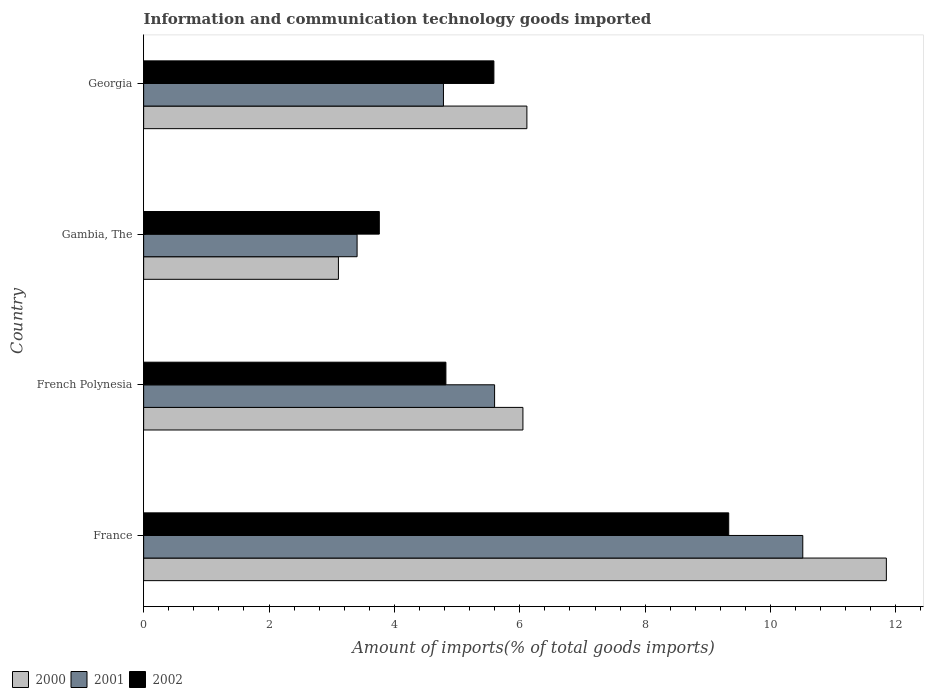How many different coloured bars are there?
Your answer should be compact. 3. How many groups of bars are there?
Offer a very short reply. 4. Are the number of bars per tick equal to the number of legend labels?
Your answer should be compact. Yes. Are the number of bars on each tick of the Y-axis equal?
Keep it short and to the point. Yes. How many bars are there on the 3rd tick from the top?
Provide a succinct answer. 3. What is the label of the 3rd group of bars from the top?
Offer a very short reply. French Polynesia. In how many cases, is the number of bars for a given country not equal to the number of legend labels?
Your answer should be very brief. 0. What is the amount of goods imported in 2000 in French Polynesia?
Offer a terse response. 6.05. Across all countries, what is the maximum amount of goods imported in 2000?
Keep it short and to the point. 11.85. Across all countries, what is the minimum amount of goods imported in 2000?
Give a very brief answer. 3.11. In which country was the amount of goods imported in 2001 minimum?
Ensure brevity in your answer.  Gambia, The. What is the total amount of goods imported in 2002 in the graph?
Offer a terse response. 23.5. What is the difference between the amount of goods imported in 2001 in French Polynesia and that in Gambia, The?
Your answer should be very brief. 2.19. What is the difference between the amount of goods imported in 2000 in Gambia, The and the amount of goods imported in 2001 in Georgia?
Provide a succinct answer. -1.68. What is the average amount of goods imported in 2002 per country?
Provide a short and direct response. 5.88. What is the difference between the amount of goods imported in 2000 and amount of goods imported in 2001 in France?
Give a very brief answer. 1.33. What is the ratio of the amount of goods imported in 2002 in France to that in French Polynesia?
Your answer should be very brief. 1.94. What is the difference between the highest and the second highest amount of goods imported in 2001?
Ensure brevity in your answer.  4.92. What is the difference between the highest and the lowest amount of goods imported in 2001?
Give a very brief answer. 7.11. Is the sum of the amount of goods imported in 2000 in France and French Polynesia greater than the maximum amount of goods imported in 2001 across all countries?
Your answer should be compact. Yes. Is it the case that in every country, the sum of the amount of goods imported in 2002 and amount of goods imported in 2000 is greater than the amount of goods imported in 2001?
Offer a very short reply. Yes. How many bars are there?
Your answer should be compact. 12. Are the values on the major ticks of X-axis written in scientific E-notation?
Offer a very short reply. No. Does the graph contain any zero values?
Ensure brevity in your answer.  No. Where does the legend appear in the graph?
Keep it short and to the point. Bottom left. How are the legend labels stacked?
Offer a very short reply. Horizontal. What is the title of the graph?
Your answer should be compact. Information and communication technology goods imported. What is the label or title of the X-axis?
Provide a succinct answer. Amount of imports(% of total goods imports). What is the label or title of the Y-axis?
Keep it short and to the point. Country. What is the Amount of imports(% of total goods imports) in 2000 in France?
Your response must be concise. 11.85. What is the Amount of imports(% of total goods imports) in 2001 in France?
Keep it short and to the point. 10.51. What is the Amount of imports(% of total goods imports) in 2002 in France?
Ensure brevity in your answer.  9.33. What is the Amount of imports(% of total goods imports) of 2000 in French Polynesia?
Your answer should be compact. 6.05. What is the Amount of imports(% of total goods imports) in 2001 in French Polynesia?
Offer a very short reply. 5.6. What is the Amount of imports(% of total goods imports) of 2002 in French Polynesia?
Ensure brevity in your answer.  4.82. What is the Amount of imports(% of total goods imports) of 2000 in Gambia, The?
Provide a short and direct response. 3.11. What is the Amount of imports(% of total goods imports) in 2001 in Gambia, The?
Ensure brevity in your answer.  3.4. What is the Amount of imports(% of total goods imports) in 2002 in Gambia, The?
Provide a succinct answer. 3.76. What is the Amount of imports(% of total goods imports) in 2000 in Georgia?
Provide a short and direct response. 6.11. What is the Amount of imports(% of total goods imports) in 2001 in Georgia?
Keep it short and to the point. 4.78. What is the Amount of imports(% of total goods imports) of 2002 in Georgia?
Provide a short and direct response. 5.59. Across all countries, what is the maximum Amount of imports(% of total goods imports) of 2000?
Your answer should be very brief. 11.85. Across all countries, what is the maximum Amount of imports(% of total goods imports) of 2001?
Provide a short and direct response. 10.51. Across all countries, what is the maximum Amount of imports(% of total goods imports) in 2002?
Ensure brevity in your answer.  9.33. Across all countries, what is the minimum Amount of imports(% of total goods imports) in 2000?
Offer a terse response. 3.11. Across all countries, what is the minimum Amount of imports(% of total goods imports) of 2001?
Ensure brevity in your answer.  3.4. Across all countries, what is the minimum Amount of imports(% of total goods imports) in 2002?
Offer a terse response. 3.76. What is the total Amount of imports(% of total goods imports) in 2000 in the graph?
Your answer should be very brief. 27.12. What is the total Amount of imports(% of total goods imports) in 2001 in the graph?
Offer a very short reply. 24.3. What is the total Amount of imports(% of total goods imports) of 2002 in the graph?
Your answer should be compact. 23.5. What is the difference between the Amount of imports(% of total goods imports) in 2000 in France and that in French Polynesia?
Provide a succinct answer. 5.8. What is the difference between the Amount of imports(% of total goods imports) of 2001 in France and that in French Polynesia?
Your answer should be compact. 4.92. What is the difference between the Amount of imports(% of total goods imports) in 2002 in France and that in French Polynesia?
Offer a terse response. 4.51. What is the difference between the Amount of imports(% of total goods imports) of 2000 in France and that in Gambia, The?
Offer a terse response. 8.74. What is the difference between the Amount of imports(% of total goods imports) of 2001 in France and that in Gambia, The?
Offer a very short reply. 7.11. What is the difference between the Amount of imports(% of total goods imports) of 2002 in France and that in Gambia, The?
Ensure brevity in your answer.  5.57. What is the difference between the Amount of imports(% of total goods imports) in 2000 in France and that in Georgia?
Your answer should be compact. 5.73. What is the difference between the Amount of imports(% of total goods imports) of 2001 in France and that in Georgia?
Your response must be concise. 5.73. What is the difference between the Amount of imports(% of total goods imports) in 2002 in France and that in Georgia?
Provide a short and direct response. 3.75. What is the difference between the Amount of imports(% of total goods imports) of 2000 in French Polynesia and that in Gambia, The?
Provide a short and direct response. 2.94. What is the difference between the Amount of imports(% of total goods imports) in 2001 in French Polynesia and that in Gambia, The?
Provide a short and direct response. 2.19. What is the difference between the Amount of imports(% of total goods imports) of 2002 in French Polynesia and that in Gambia, The?
Provide a succinct answer. 1.06. What is the difference between the Amount of imports(% of total goods imports) in 2000 in French Polynesia and that in Georgia?
Give a very brief answer. -0.06. What is the difference between the Amount of imports(% of total goods imports) of 2001 in French Polynesia and that in Georgia?
Provide a succinct answer. 0.82. What is the difference between the Amount of imports(% of total goods imports) of 2002 in French Polynesia and that in Georgia?
Provide a succinct answer. -0.77. What is the difference between the Amount of imports(% of total goods imports) in 2000 in Gambia, The and that in Georgia?
Your response must be concise. -3.01. What is the difference between the Amount of imports(% of total goods imports) in 2001 in Gambia, The and that in Georgia?
Your answer should be very brief. -1.38. What is the difference between the Amount of imports(% of total goods imports) of 2002 in Gambia, The and that in Georgia?
Your answer should be compact. -1.83. What is the difference between the Amount of imports(% of total goods imports) in 2000 in France and the Amount of imports(% of total goods imports) in 2001 in French Polynesia?
Offer a terse response. 6.25. What is the difference between the Amount of imports(% of total goods imports) in 2000 in France and the Amount of imports(% of total goods imports) in 2002 in French Polynesia?
Offer a very short reply. 7.03. What is the difference between the Amount of imports(% of total goods imports) in 2001 in France and the Amount of imports(% of total goods imports) in 2002 in French Polynesia?
Your answer should be very brief. 5.69. What is the difference between the Amount of imports(% of total goods imports) of 2000 in France and the Amount of imports(% of total goods imports) of 2001 in Gambia, The?
Offer a terse response. 8.44. What is the difference between the Amount of imports(% of total goods imports) in 2000 in France and the Amount of imports(% of total goods imports) in 2002 in Gambia, The?
Keep it short and to the point. 8.09. What is the difference between the Amount of imports(% of total goods imports) in 2001 in France and the Amount of imports(% of total goods imports) in 2002 in Gambia, The?
Offer a terse response. 6.76. What is the difference between the Amount of imports(% of total goods imports) of 2000 in France and the Amount of imports(% of total goods imports) of 2001 in Georgia?
Your answer should be very brief. 7.07. What is the difference between the Amount of imports(% of total goods imports) of 2000 in France and the Amount of imports(% of total goods imports) of 2002 in Georgia?
Provide a succinct answer. 6.26. What is the difference between the Amount of imports(% of total goods imports) of 2001 in France and the Amount of imports(% of total goods imports) of 2002 in Georgia?
Keep it short and to the point. 4.93. What is the difference between the Amount of imports(% of total goods imports) in 2000 in French Polynesia and the Amount of imports(% of total goods imports) in 2001 in Gambia, The?
Give a very brief answer. 2.65. What is the difference between the Amount of imports(% of total goods imports) of 2000 in French Polynesia and the Amount of imports(% of total goods imports) of 2002 in Gambia, The?
Make the answer very short. 2.29. What is the difference between the Amount of imports(% of total goods imports) of 2001 in French Polynesia and the Amount of imports(% of total goods imports) of 2002 in Gambia, The?
Ensure brevity in your answer.  1.84. What is the difference between the Amount of imports(% of total goods imports) in 2000 in French Polynesia and the Amount of imports(% of total goods imports) in 2001 in Georgia?
Keep it short and to the point. 1.27. What is the difference between the Amount of imports(% of total goods imports) in 2000 in French Polynesia and the Amount of imports(% of total goods imports) in 2002 in Georgia?
Your answer should be very brief. 0.46. What is the difference between the Amount of imports(% of total goods imports) in 2001 in French Polynesia and the Amount of imports(% of total goods imports) in 2002 in Georgia?
Your response must be concise. 0.01. What is the difference between the Amount of imports(% of total goods imports) of 2000 in Gambia, The and the Amount of imports(% of total goods imports) of 2001 in Georgia?
Keep it short and to the point. -1.68. What is the difference between the Amount of imports(% of total goods imports) in 2000 in Gambia, The and the Amount of imports(% of total goods imports) in 2002 in Georgia?
Your answer should be compact. -2.48. What is the difference between the Amount of imports(% of total goods imports) of 2001 in Gambia, The and the Amount of imports(% of total goods imports) of 2002 in Georgia?
Keep it short and to the point. -2.18. What is the average Amount of imports(% of total goods imports) in 2000 per country?
Provide a succinct answer. 6.78. What is the average Amount of imports(% of total goods imports) in 2001 per country?
Provide a succinct answer. 6.08. What is the average Amount of imports(% of total goods imports) of 2002 per country?
Offer a very short reply. 5.88. What is the difference between the Amount of imports(% of total goods imports) of 2000 and Amount of imports(% of total goods imports) of 2001 in France?
Your response must be concise. 1.33. What is the difference between the Amount of imports(% of total goods imports) of 2000 and Amount of imports(% of total goods imports) of 2002 in France?
Keep it short and to the point. 2.51. What is the difference between the Amount of imports(% of total goods imports) in 2001 and Amount of imports(% of total goods imports) in 2002 in France?
Provide a short and direct response. 1.18. What is the difference between the Amount of imports(% of total goods imports) of 2000 and Amount of imports(% of total goods imports) of 2001 in French Polynesia?
Offer a very short reply. 0.45. What is the difference between the Amount of imports(% of total goods imports) in 2000 and Amount of imports(% of total goods imports) in 2002 in French Polynesia?
Give a very brief answer. 1.23. What is the difference between the Amount of imports(% of total goods imports) in 2001 and Amount of imports(% of total goods imports) in 2002 in French Polynesia?
Your answer should be compact. 0.78. What is the difference between the Amount of imports(% of total goods imports) in 2000 and Amount of imports(% of total goods imports) in 2001 in Gambia, The?
Keep it short and to the point. -0.3. What is the difference between the Amount of imports(% of total goods imports) of 2000 and Amount of imports(% of total goods imports) of 2002 in Gambia, The?
Offer a very short reply. -0.65. What is the difference between the Amount of imports(% of total goods imports) of 2001 and Amount of imports(% of total goods imports) of 2002 in Gambia, The?
Keep it short and to the point. -0.35. What is the difference between the Amount of imports(% of total goods imports) in 2000 and Amount of imports(% of total goods imports) in 2001 in Georgia?
Give a very brief answer. 1.33. What is the difference between the Amount of imports(% of total goods imports) of 2000 and Amount of imports(% of total goods imports) of 2002 in Georgia?
Make the answer very short. 0.53. What is the difference between the Amount of imports(% of total goods imports) of 2001 and Amount of imports(% of total goods imports) of 2002 in Georgia?
Offer a very short reply. -0.8. What is the ratio of the Amount of imports(% of total goods imports) in 2000 in France to that in French Polynesia?
Your answer should be very brief. 1.96. What is the ratio of the Amount of imports(% of total goods imports) of 2001 in France to that in French Polynesia?
Your answer should be compact. 1.88. What is the ratio of the Amount of imports(% of total goods imports) of 2002 in France to that in French Polynesia?
Make the answer very short. 1.94. What is the ratio of the Amount of imports(% of total goods imports) of 2000 in France to that in Gambia, The?
Provide a succinct answer. 3.81. What is the ratio of the Amount of imports(% of total goods imports) of 2001 in France to that in Gambia, The?
Keep it short and to the point. 3.09. What is the ratio of the Amount of imports(% of total goods imports) in 2002 in France to that in Gambia, The?
Your response must be concise. 2.48. What is the ratio of the Amount of imports(% of total goods imports) in 2000 in France to that in Georgia?
Offer a terse response. 1.94. What is the ratio of the Amount of imports(% of total goods imports) of 2001 in France to that in Georgia?
Provide a succinct answer. 2.2. What is the ratio of the Amount of imports(% of total goods imports) of 2002 in France to that in Georgia?
Offer a very short reply. 1.67. What is the ratio of the Amount of imports(% of total goods imports) of 2000 in French Polynesia to that in Gambia, The?
Ensure brevity in your answer.  1.95. What is the ratio of the Amount of imports(% of total goods imports) of 2001 in French Polynesia to that in Gambia, The?
Your answer should be compact. 1.64. What is the ratio of the Amount of imports(% of total goods imports) in 2002 in French Polynesia to that in Gambia, The?
Make the answer very short. 1.28. What is the ratio of the Amount of imports(% of total goods imports) of 2000 in French Polynesia to that in Georgia?
Your answer should be compact. 0.99. What is the ratio of the Amount of imports(% of total goods imports) in 2001 in French Polynesia to that in Georgia?
Offer a very short reply. 1.17. What is the ratio of the Amount of imports(% of total goods imports) in 2002 in French Polynesia to that in Georgia?
Provide a short and direct response. 0.86. What is the ratio of the Amount of imports(% of total goods imports) in 2000 in Gambia, The to that in Georgia?
Your answer should be very brief. 0.51. What is the ratio of the Amount of imports(% of total goods imports) of 2001 in Gambia, The to that in Georgia?
Make the answer very short. 0.71. What is the ratio of the Amount of imports(% of total goods imports) in 2002 in Gambia, The to that in Georgia?
Provide a short and direct response. 0.67. What is the difference between the highest and the second highest Amount of imports(% of total goods imports) in 2000?
Make the answer very short. 5.73. What is the difference between the highest and the second highest Amount of imports(% of total goods imports) of 2001?
Your answer should be very brief. 4.92. What is the difference between the highest and the second highest Amount of imports(% of total goods imports) of 2002?
Offer a terse response. 3.75. What is the difference between the highest and the lowest Amount of imports(% of total goods imports) of 2000?
Your answer should be compact. 8.74. What is the difference between the highest and the lowest Amount of imports(% of total goods imports) in 2001?
Keep it short and to the point. 7.11. What is the difference between the highest and the lowest Amount of imports(% of total goods imports) in 2002?
Your response must be concise. 5.57. 